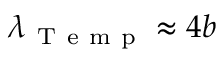<formula> <loc_0><loc_0><loc_500><loc_500>\lambda _ { T e m p } \approx 4 b</formula> 